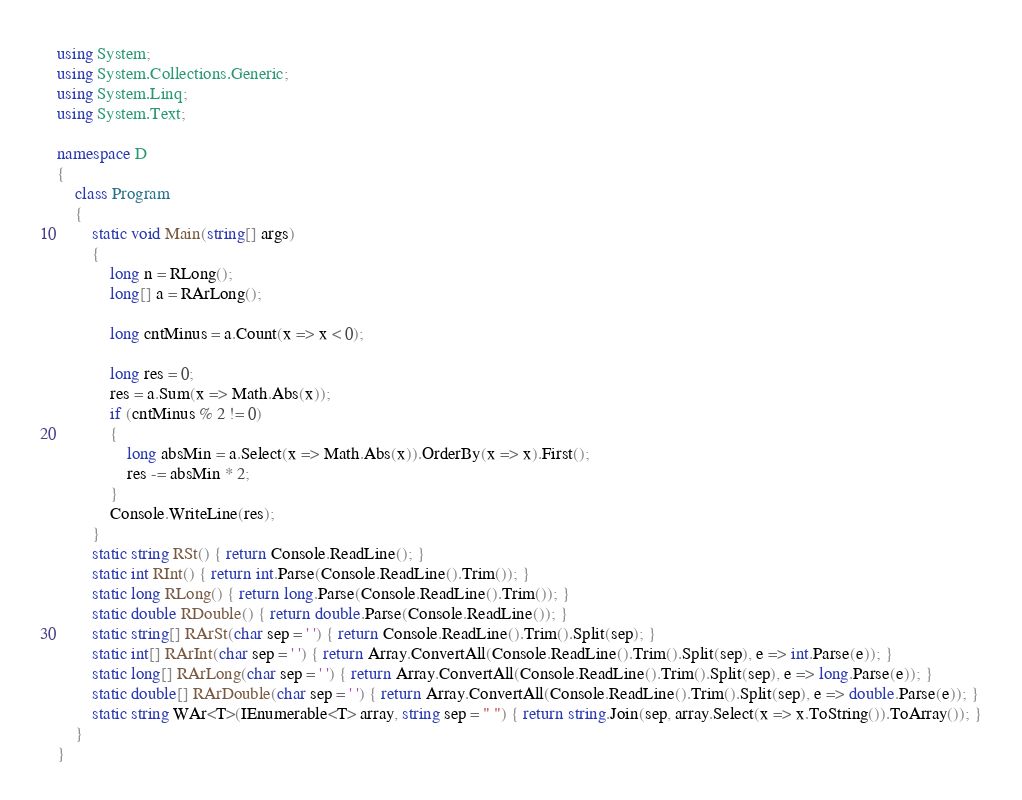<code> <loc_0><loc_0><loc_500><loc_500><_C#_>using System;
using System.Collections.Generic;
using System.Linq;
using System.Text;

namespace D
{
    class Program
    {
        static void Main(string[] args)
        {
            long n = RLong();
            long[] a = RArLong();

            long cntMinus = a.Count(x => x < 0);

            long res = 0;
            res = a.Sum(x => Math.Abs(x));
            if (cntMinus % 2 != 0)
            {
                long absMin = a.Select(x => Math.Abs(x)).OrderBy(x => x).First();
                res -= absMin * 2;
            }
            Console.WriteLine(res);
        }
        static string RSt() { return Console.ReadLine(); }
        static int RInt() { return int.Parse(Console.ReadLine().Trim()); }
        static long RLong() { return long.Parse(Console.ReadLine().Trim()); }
        static double RDouble() { return double.Parse(Console.ReadLine()); }
        static string[] RArSt(char sep = ' ') { return Console.ReadLine().Trim().Split(sep); }
        static int[] RArInt(char sep = ' ') { return Array.ConvertAll(Console.ReadLine().Trim().Split(sep), e => int.Parse(e)); }
        static long[] RArLong(char sep = ' ') { return Array.ConvertAll(Console.ReadLine().Trim().Split(sep), e => long.Parse(e)); }
        static double[] RArDouble(char sep = ' ') { return Array.ConvertAll(Console.ReadLine().Trim().Split(sep), e => double.Parse(e)); }
        static string WAr<T>(IEnumerable<T> array, string sep = " ") { return string.Join(sep, array.Select(x => x.ToString()).ToArray()); }
    }
}
</code> 